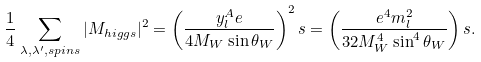<formula> <loc_0><loc_0><loc_500><loc_500>\frac { 1 } { 4 } \sum _ { \lambda , \lambda ^ { \prime } , s p i n s } | M _ { h i g g s } | ^ { 2 } = \left ( \frac { y ^ { A } _ { l } e } { 4 M _ { W } \sin \theta _ { W } } \right ) ^ { 2 } s = \left ( \frac { e ^ { 4 } m ^ { 2 } _ { l } } { 3 2 M ^ { 4 } _ { W } \sin ^ { 4 } \theta _ { W } } \right ) s .</formula> 